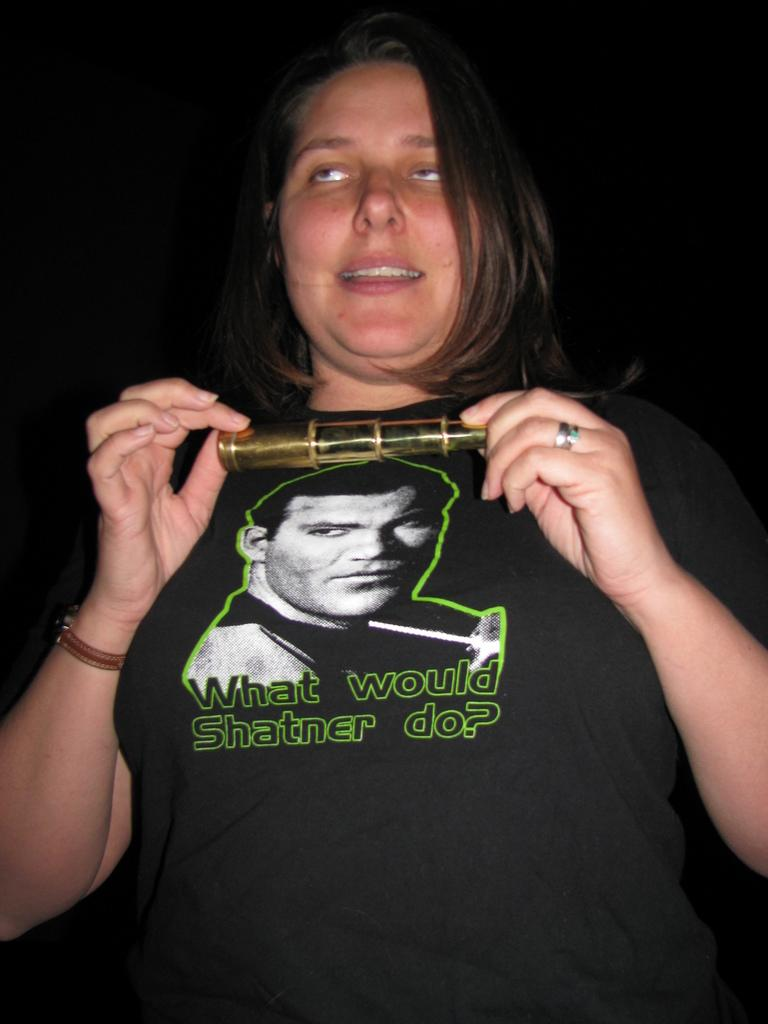What is present in the image? There is a woman in the image. What is the woman doing in the image? The woman is holding an object in her hand. What is the temperature of the object the woman is holding in the image? The provided facts do not mention the temperature of the object, so we cannot determine the heat level from the image. 